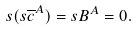<formula> <loc_0><loc_0><loc_500><loc_500>s ( s \overline { c } ^ { A } ) = s B ^ { A } = 0 .</formula> 